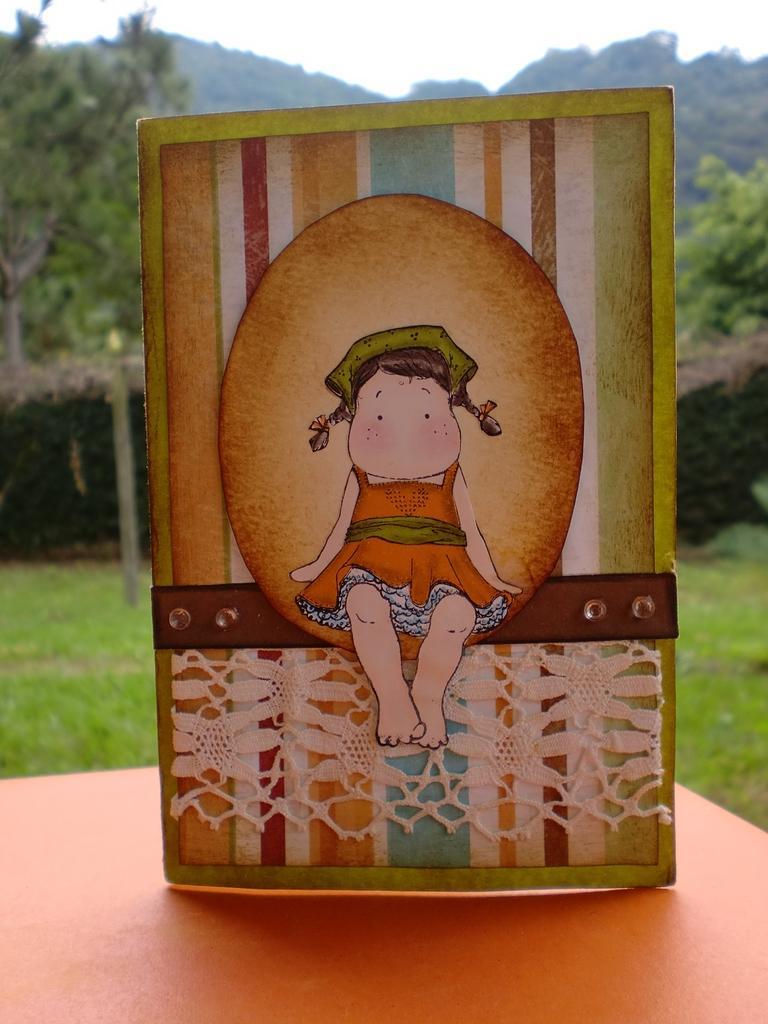Describe this image in one or two sentences. At the bottom of this image I can see a table on which I card is visible. On this card I can see a painting of a girl. In the background, I can see the grass and trees. On the top of the image I can see the sky. 